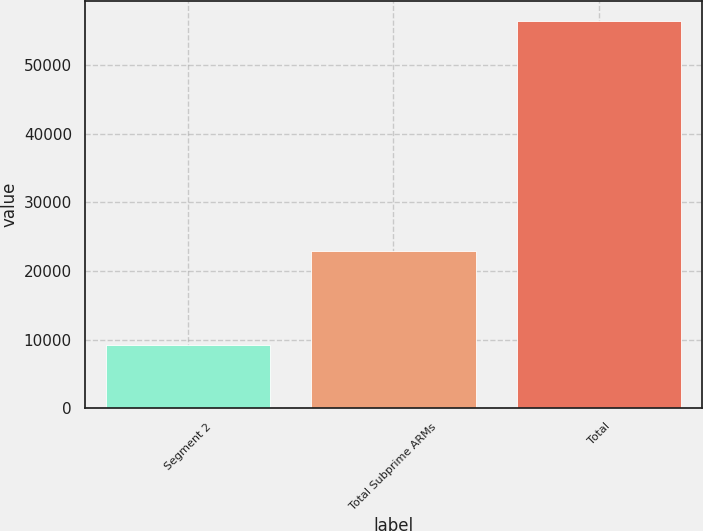Convert chart to OTSL. <chart><loc_0><loc_0><loc_500><loc_500><bar_chart><fcel>Segment 2<fcel>Total Subprime ARMs<fcel>Total<nl><fcel>9135<fcel>22879<fcel>56454<nl></chart> 